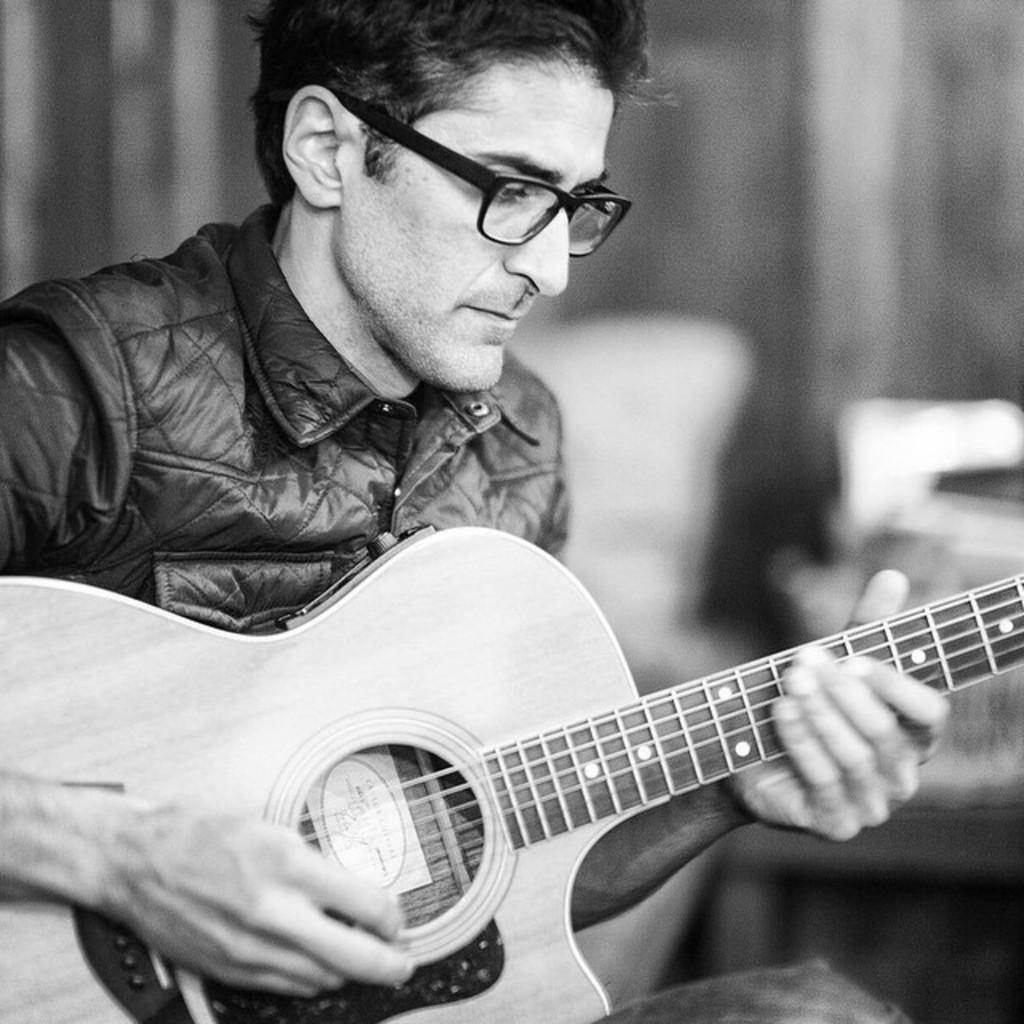Who is the main subject in the image? There is a man in the image. What is the man wearing? The man is wearing a jacket. What activity is the man engaged in? The man is playing the guitar. What type of bear can be seen playing the guitar alongside the man in the image? There is no bear present in the image; it only features a man playing the guitar. How many hairs can be counted on the man's toe in the image? The image does not provide enough detail to count individual hairs on the man's toe. 